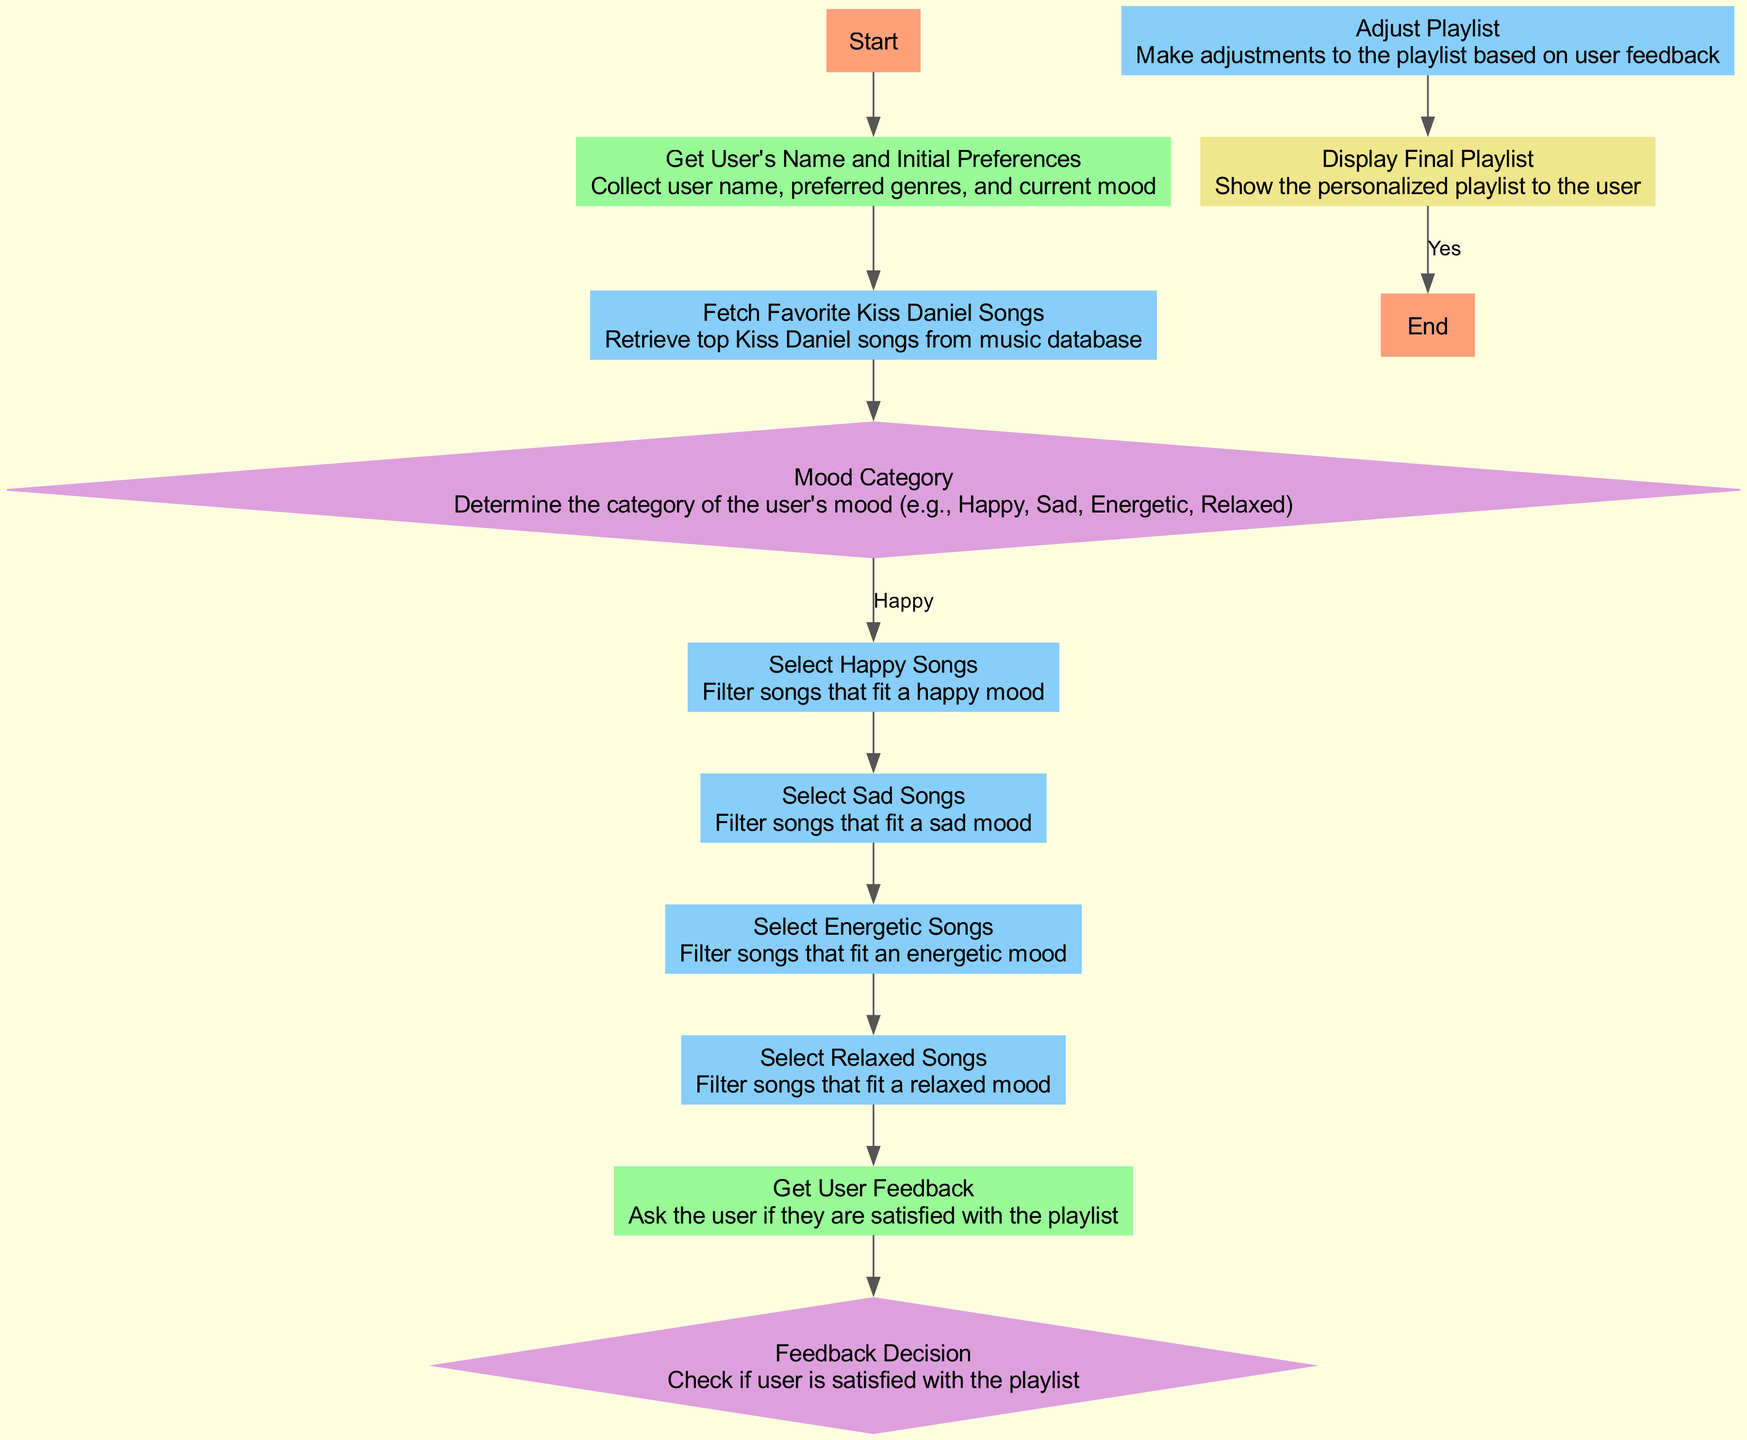How many nodes are in the diagram? By counting all the elements in the flowchart, we find labels for "Start," "Get User's Name and Initial Preferences," "Fetch Favorite Kiss Daniel Songs," "Mood Category," four song selection processes, "Get User Feedback," "Feedback Decision," "Adjust Playlist," "Display Final Playlist," and "End." This totals 12 nodes.
Answer: 12 What is the last action performed before the "End"? The flowchart shows that the action performed just before reaching "End" is "Display Final Playlist," which indicates the process of showing the personalized playlist to the user.
Answer: Display Final Playlist What genres are selected based on the user's mood? The nodes for selecting songs include "Select Happy Songs," "Select Sad Songs," "Select Energetic Songs," and "Select Relaxed Songs," which correspond to the various mood categories identified in the decision process.
Answer: Happy, Sad, Energetic, Relaxed What happens if the user is satisfied with the playlist? If the user is satisfied as indicated in the "Feedback Decision," the flow moves directly to "Display Final Playlist," meaning no adjustments are made to the playlist before it is shown to the user.
Answer: Display Final Playlist Which nodes are categorized as decision nodes? In the flowchart, the decision nodes are "Mood Category" and "Feedback Decision," where the flow diverges based on the user's mood and satisfaction feedback, respectively.
Answer: Mood Category, Feedback Decision What does the flowchart recommend if the user's mood is "Sad"? According to the flowchart's branches, if the user's mood is determined to be "Sad," the process leads to "Select Sad Songs," which filters the songs that fit a sad mood.
Answer: Select Sad Songs What input is collected at the beginning of the process? The first input node is "Get User's Name and Initial Preferences," which gathers the user's name, preferred genres, and current mood.
Answer: Get User's Name and Initial Preferences What occurs after "Get User Feedback"? Following the "Get User Feedback," the flow proceeds to the "Feedback Decision" node, where the user's satisfaction with the playlist is evaluated.
Answer: Feedback Decision What action precedes "Adjust Playlist"? The action that precedes "Adjust Playlist" is "Feedback Decision," where the user's feedback determines if adjustments are necessary based on their satisfaction with the playlist.
Answer: Feedback Decision 